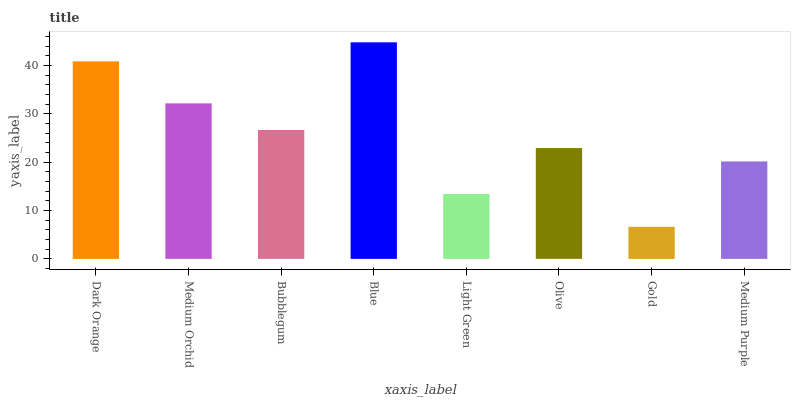Is Medium Orchid the minimum?
Answer yes or no. No. Is Medium Orchid the maximum?
Answer yes or no. No. Is Dark Orange greater than Medium Orchid?
Answer yes or no. Yes. Is Medium Orchid less than Dark Orange?
Answer yes or no. Yes. Is Medium Orchid greater than Dark Orange?
Answer yes or no. No. Is Dark Orange less than Medium Orchid?
Answer yes or no. No. Is Bubblegum the high median?
Answer yes or no. Yes. Is Olive the low median?
Answer yes or no. Yes. Is Blue the high median?
Answer yes or no. No. Is Medium Purple the low median?
Answer yes or no. No. 